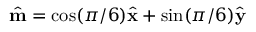Convert formula to latex. <formula><loc_0><loc_0><loc_500><loc_500>\hat { m } = \cos ( \pi / 6 ) \hat { x } + \sin ( \pi / 6 ) \hat { y }</formula> 